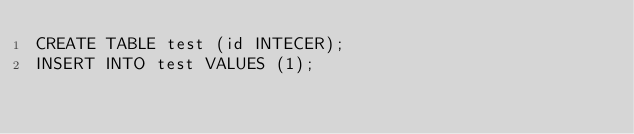<code> <loc_0><loc_0><loc_500><loc_500><_SQL_>CREATE TABLE test (id INTECER);
INSERT INTO test VALUES (1);</code> 